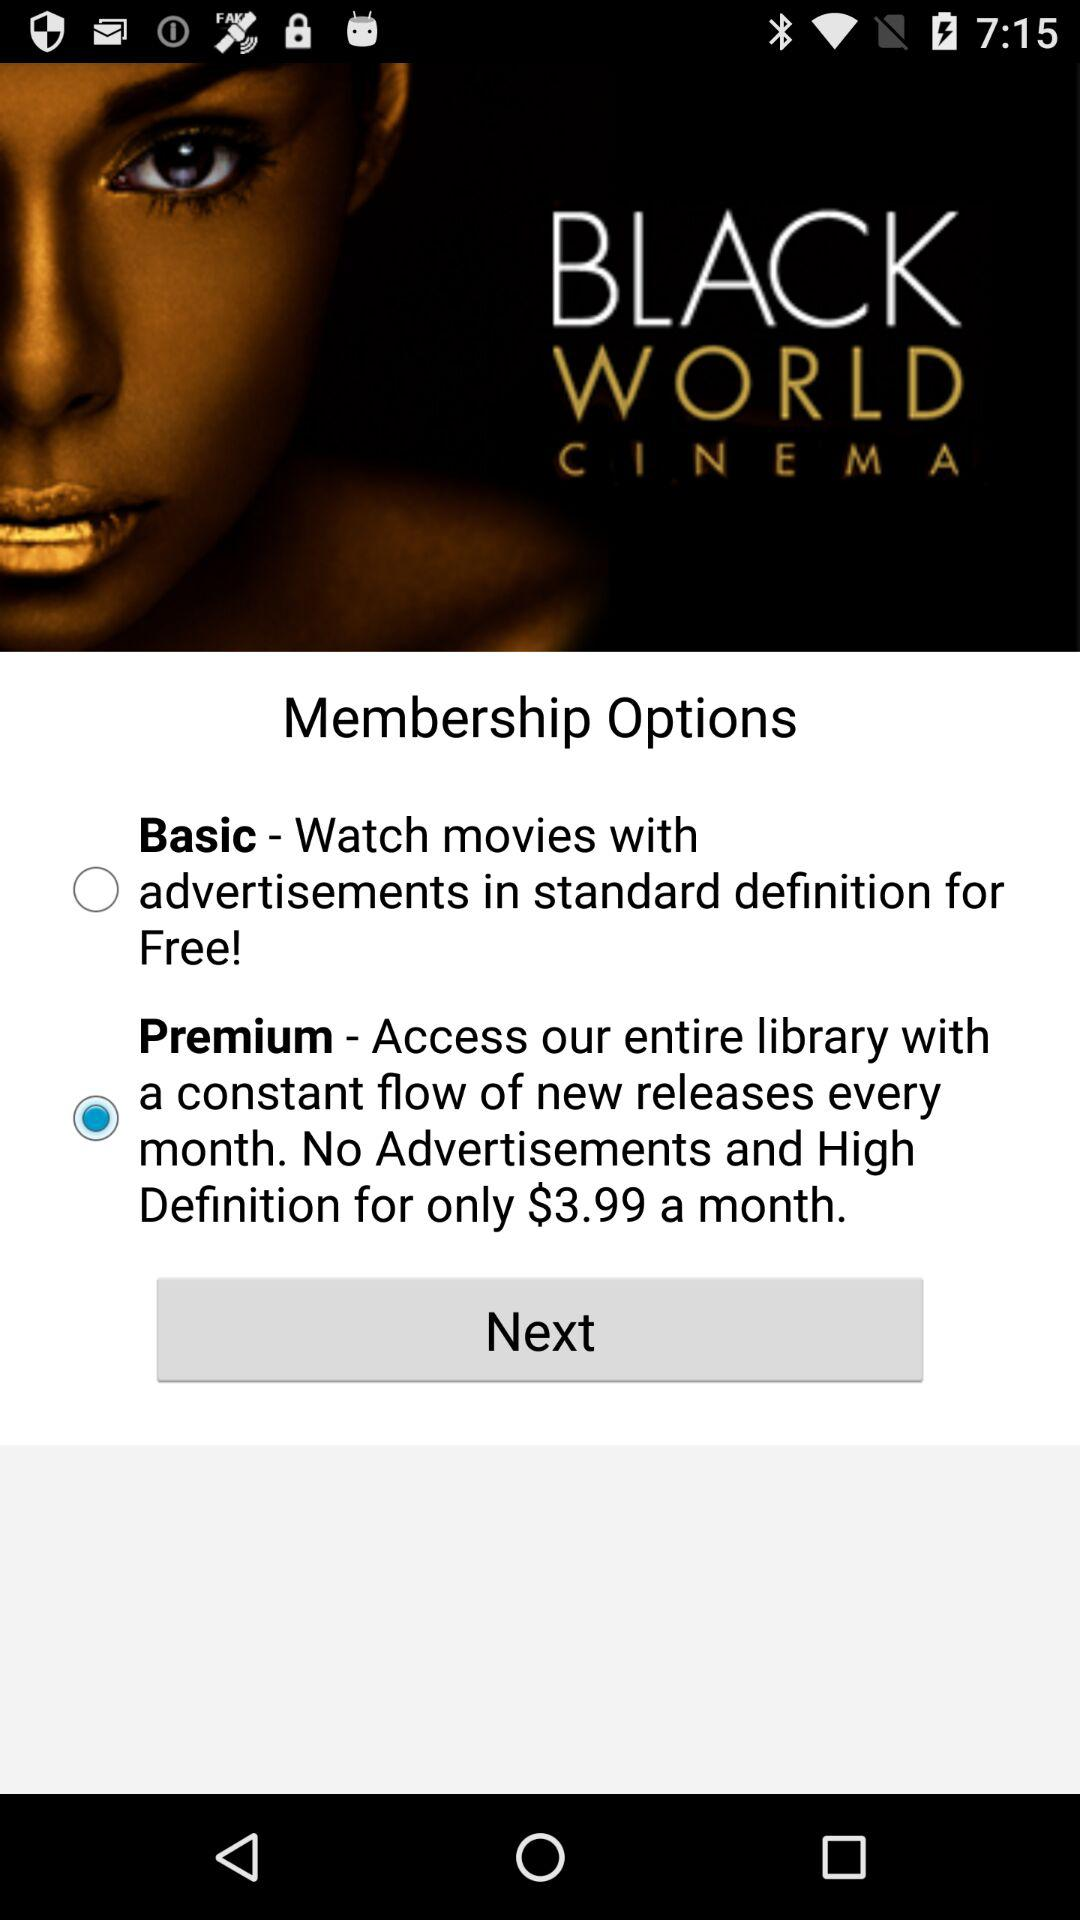How much more does the premium plan cost than the basic plan?
Answer the question using a single word or phrase. $3.99 